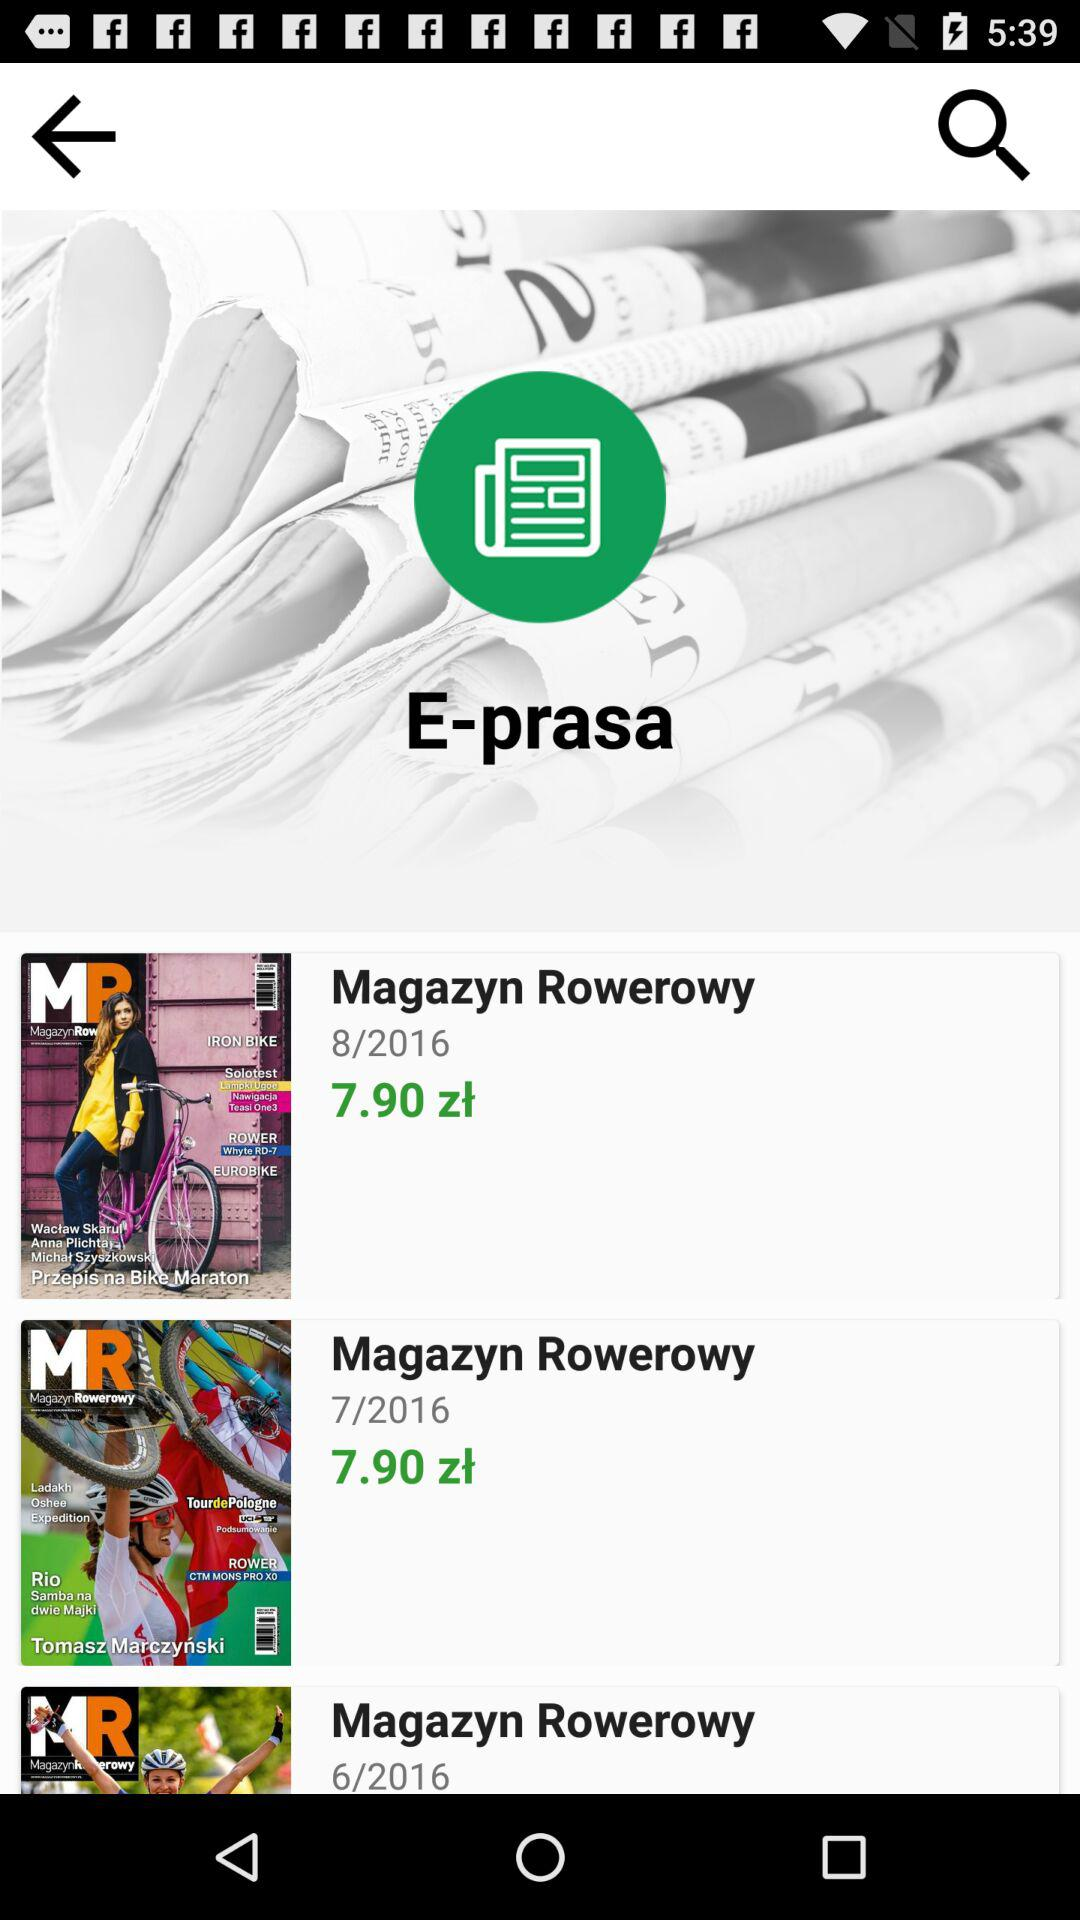How many issues of Magazyn Rowerowy are shown?
Answer the question using a single word or phrase. 3 